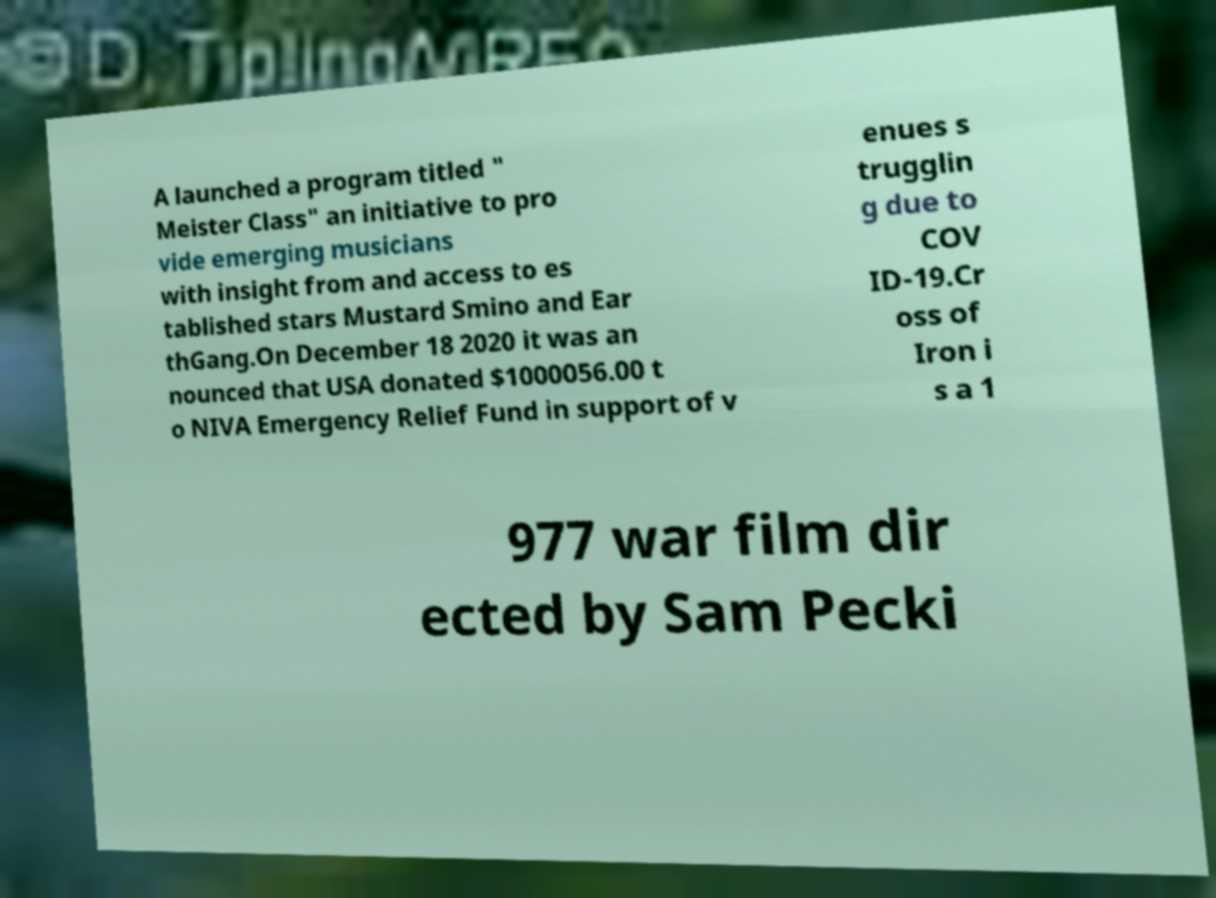Please identify and transcribe the text found in this image. A launched a program titled " Meister Class" an initiative to pro vide emerging musicians with insight from and access to es tablished stars Mustard Smino and Ear thGang.On December 18 2020 it was an nounced that USA donated $1000056.00 t o NIVA Emergency Relief Fund in support of v enues s trugglin g due to COV ID-19.Cr oss of Iron i s a 1 977 war film dir ected by Sam Pecki 